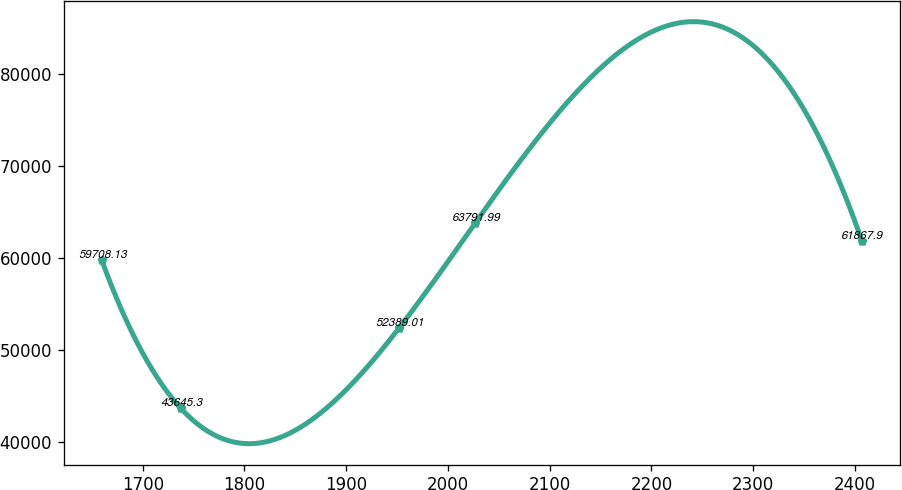<chart> <loc_0><loc_0><loc_500><loc_500><line_chart><ecel><fcel>Unnamed: 1<nl><fcel>1659.77<fcel>59708.1<nl><fcel>1737.18<fcel>43645.3<nl><fcel>1952.22<fcel>52389<nl><fcel>2026.93<fcel>63792<nl><fcel>2406.88<fcel>61867.9<nl></chart> 